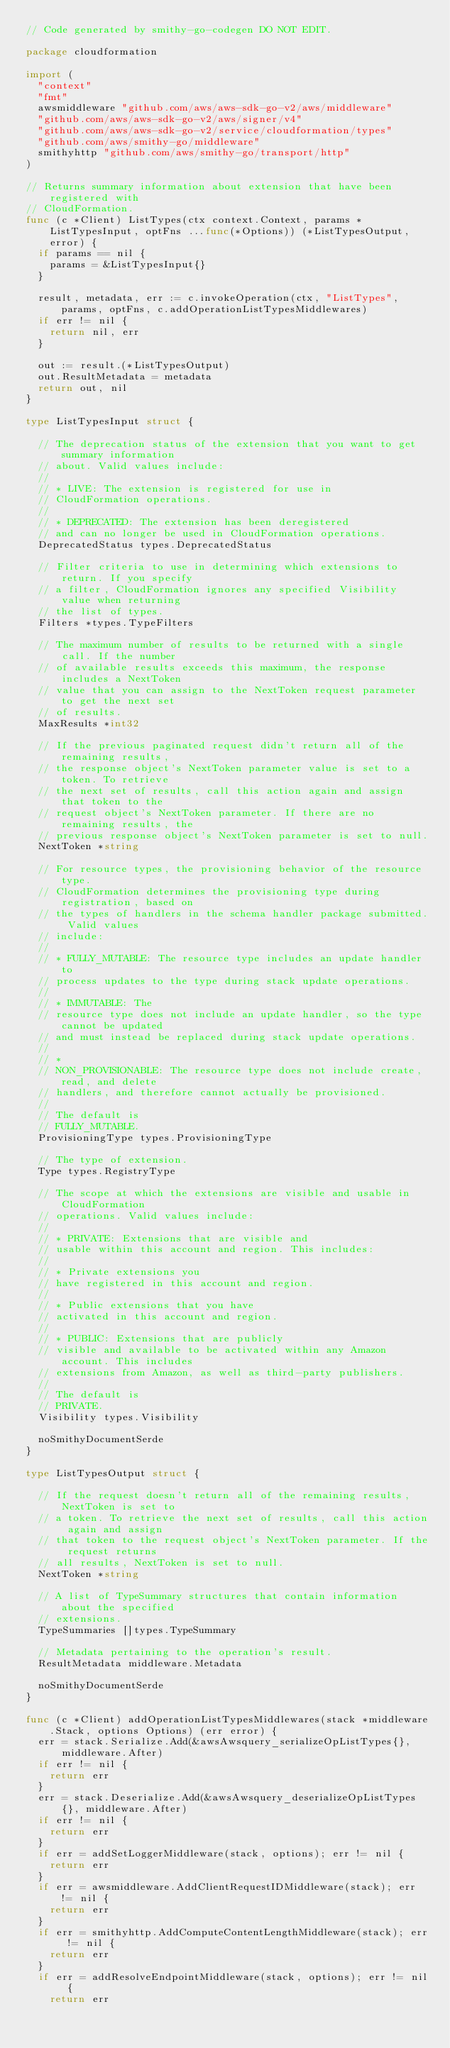<code> <loc_0><loc_0><loc_500><loc_500><_Go_>// Code generated by smithy-go-codegen DO NOT EDIT.

package cloudformation

import (
	"context"
	"fmt"
	awsmiddleware "github.com/aws/aws-sdk-go-v2/aws/middleware"
	"github.com/aws/aws-sdk-go-v2/aws/signer/v4"
	"github.com/aws/aws-sdk-go-v2/service/cloudformation/types"
	"github.com/aws/smithy-go/middleware"
	smithyhttp "github.com/aws/smithy-go/transport/http"
)

// Returns summary information about extension that have been registered with
// CloudFormation.
func (c *Client) ListTypes(ctx context.Context, params *ListTypesInput, optFns ...func(*Options)) (*ListTypesOutput, error) {
	if params == nil {
		params = &ListTypesInput{}
	}

	result, metadata, err := c.invokeOperation(ctx, "ListTypes", params, optFns, c.addOperationListTypesMiddlewares)
	if err != nil {
		return nil, err
	}

	out := result.(*ListTypesOutput)
	out.ResultMetadata = metadata
	return out, nil
}

type ListTypesInput struct {

	// The deprecation status of the extension that you want to get summary information
	// about. Valid values include:
	//
	// * LIVE: The extension is registered for use in
	// CloudFormation operations.
	//
	// * DEPRECATED: The extension has been deregistered
	// and can no longer be used in CloudFormation operations.
	DeprecatedStatus types.DeprecatedStatus

	// Filter criteria to use in determining which extensions to return. If you specify
	// a filter, CloudFormation ignores any specified Visibility value when returning
	// the list of types.
	Filters *types.TypeFilters

	// The maximum number of results to be returned with a single call. If the number
	// of available results exceeds this maximum, the response includes a NextToken
	// value that you can assign to the NextToken request parameter to get the next set
	// of results.
	MaxResults *int32

	// If the previous paginated request didn't return all of the remaining results,
	// the response object's NextToken parameter value is set to a token. To retrieve
	// the next set of results, call this action again and assign that token to the
	// request object's NextToken parameter. If there are no remaining results, the
	// previous response object's NextToken parameter is set to null.
	NextToken *string

	// For resource types, the provisioning behavior of the resource type.
	// CloudFormation determines the provisioning type during registration, based on
	// the types of handlers in the schema handler package submitted. Valid values
	// include:
	//
	// * FULLY_MUTABLE: The resource type includes an update handler to
	// process updates to the type during stack update operations.
	//
	// * IMMUTABLE: The
	// resource type does not include an update handler, so the type cannot be updated
	// and must instead be replaced during stack update operations.
	//
	// *
	// NON_PROVISIONABLE: The resource type does not include create, read, and delete
	// handlers, and therefore cannot actually be provisioned.
	//
	// The default is
	// FULLY_MUTABLE.
	ProvisioningType types.ProvisioningType

	// The type of extension.
	Type types.RegistryType

	// The scope at which the extensions are visible and usable in CloudFormation
	// operations. Valid values include:
	//
	// * PRIVATE: Extensions that are visible and
	// usable within this account and region. This includes:
	//
	// * Private extensions you
	// have registered in this account and region.
	//
	// * Public extensions that you have
	// activated in this account and region.
	//
	// * PUBLIC: Extensions that are publicly
	// visible and available to be activated within any Amazon account. This includes
	// extensions from Amazon, as well as third-party publishers.
	//
	// The default is
	// PRIVATE.
	Visibility types.Visibility

	noSmithyDocumentSerde
}

type ListTypesOutput struct {

	// If the request doesn't return all of the remaining results, NextToken is set to
	// a token. To retrieve the next set of results, call this action again and assign
	// that token to the request object's NextToken parameter. If the request returns
	// all results, NextToken is set to null.
	NextToken *string

	// A list of TypeSummary structures that contain information about the specified
	// extensions.
	TypeSummaries []types.TypeSummary

	// Metadata pertaining to the operation's result.
	ResultMetadata middleware.Metadata

	noSmithyDocumentSerde
}

func (c *Client) addOperationListTypesMiddlewares(stack *middleware.Stack, options Options) (err error) {
	err = stack.Serialize.Add(&awsAwsquery_serializeOpListTypes{}, middleware.After)
	if err != nil {
		return err
	}
	err = stack.Deserialize.Add(&awsAwsquery_deserializeOpListTypes{}, middleware.After)
	if err != nil {
		return err
	}
	if err = addSetLoggerMiddleware(stack, options); err != nil {
		return err
	}
	if err = awsmiddleware.AddClientRequestIDMiddleware(stack); err != nil {
		return err
	}
	if err = smithyhttp.AddComputeContentLengthMiddleware(stack); err != nil {
		return err
	}
	if err = addResolveEndpointMiddleware(stack, options); err != nil {
		return err</code> 